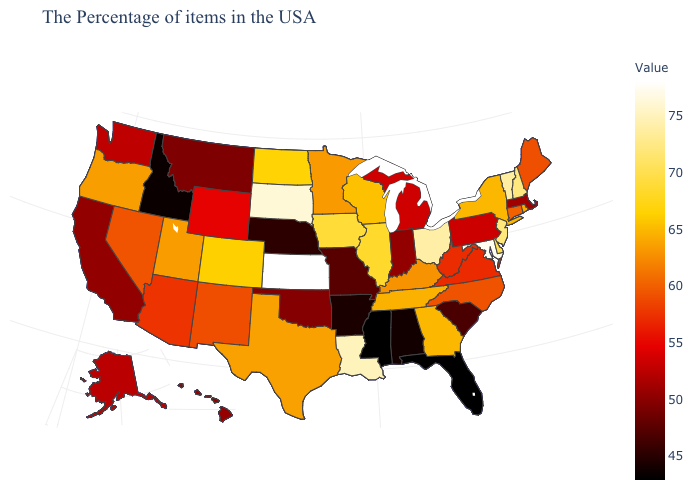Which states hav the highest value in the West?
Quick response, please. Colorado. Does Rhode Island have the highest value in the USA?
Keep it brief. No. Which states have the highest value in the USA?
Give a very brief answer. Kansas. Which states have the lowest value in the Northeast?
Give a very brief answer. Massachusetts. Is the legend a continuous bar?
Write a very short answer. Yes. Among the states that border Pennsylvania , which have the highest value?
Write a very short answer. Maryland. Among the states that border Massachusetts , does Connecticut have the lowest value?
Concise answer only. Yes. 